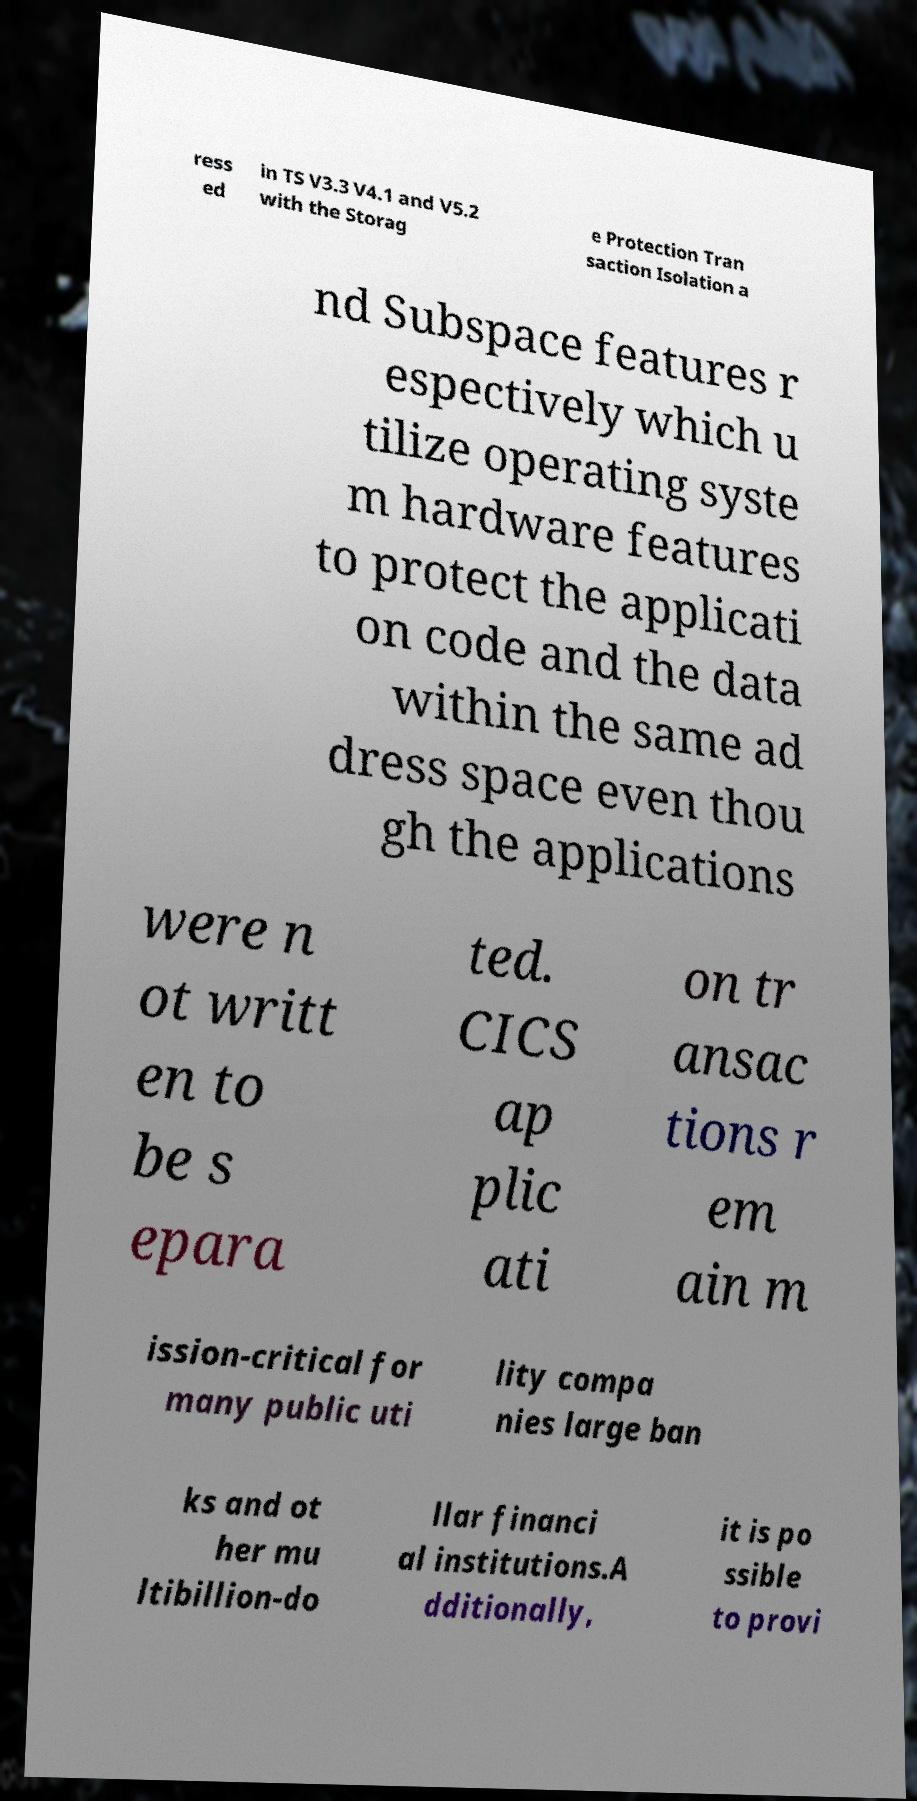Please read and relay the text visible in this image. What does it say? ress ed in TS V3.3 V4.1 and V5.2 with the Storag e Protection Tran saction Isolation a nd Subspace features r espectively which u tilize operating syste m hardware features to protect the applicati on code and the data within the same ad dress space even thou gh the applications were n ot writt en to be s epara ted. CICS ap plic ati on tr ansac tions r em ain m ission-critical for many public uti lity compa nies large ban ks and ot her mu ltibillion-do llar financi al institutions.A dditionally, it is po ssible to provi 